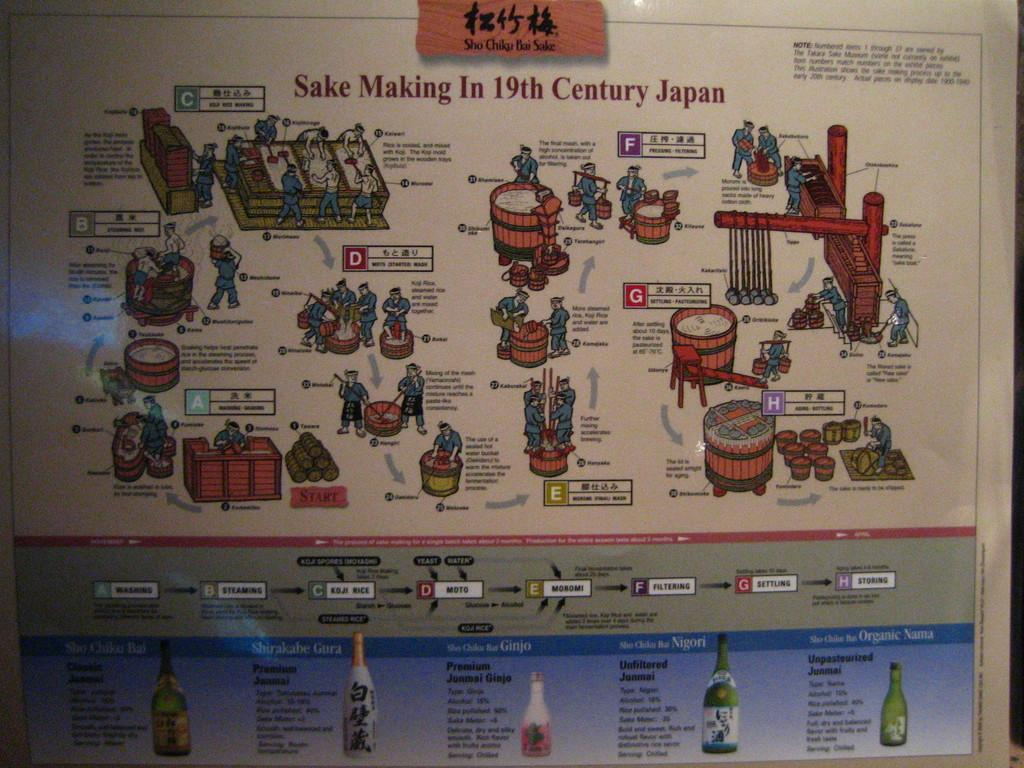<image>
Create a compact narrative representing the image presented. a poster that details the making of an item in 19th century Japan 